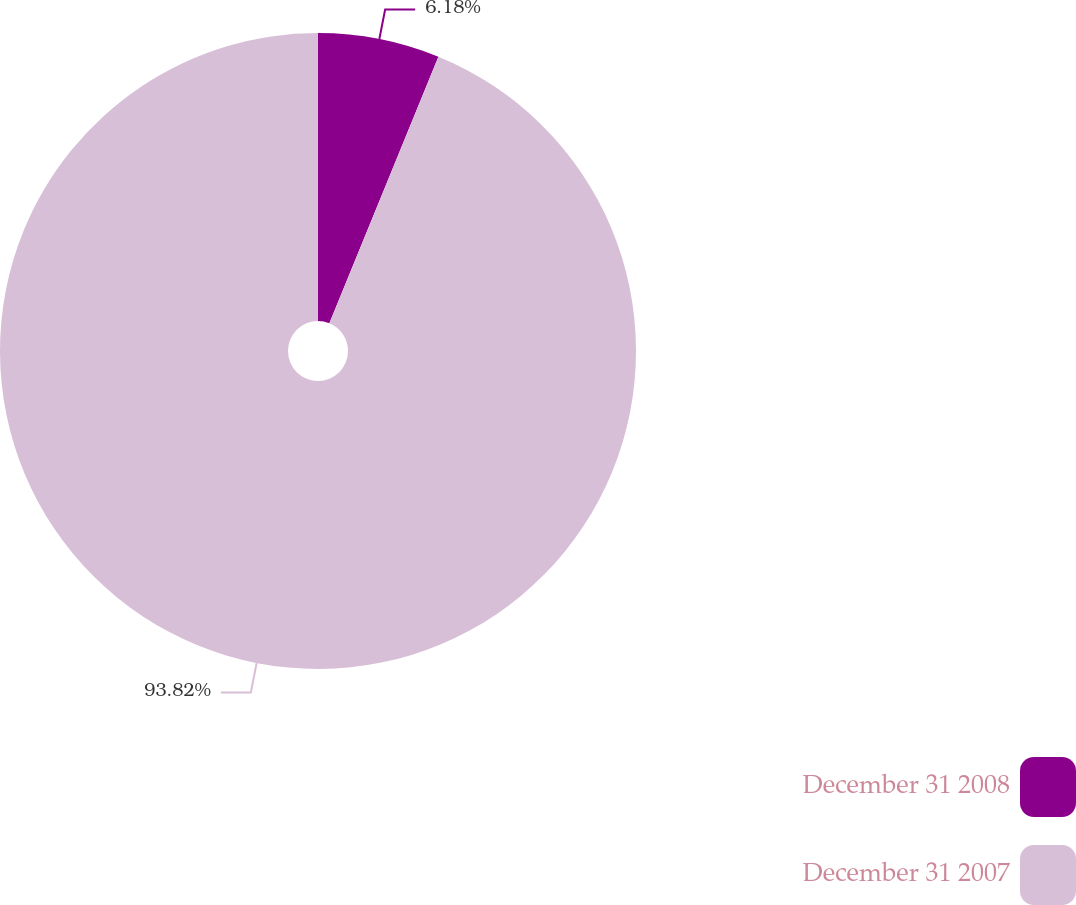Convert chart. <chart><loc_0><loc_0><loc_500><loc_500><pie_chart><fcel>December 31 2008<fcel>December 31 2007<nl><fcel>6.18%<fcel>93.82%<nl></chart> 